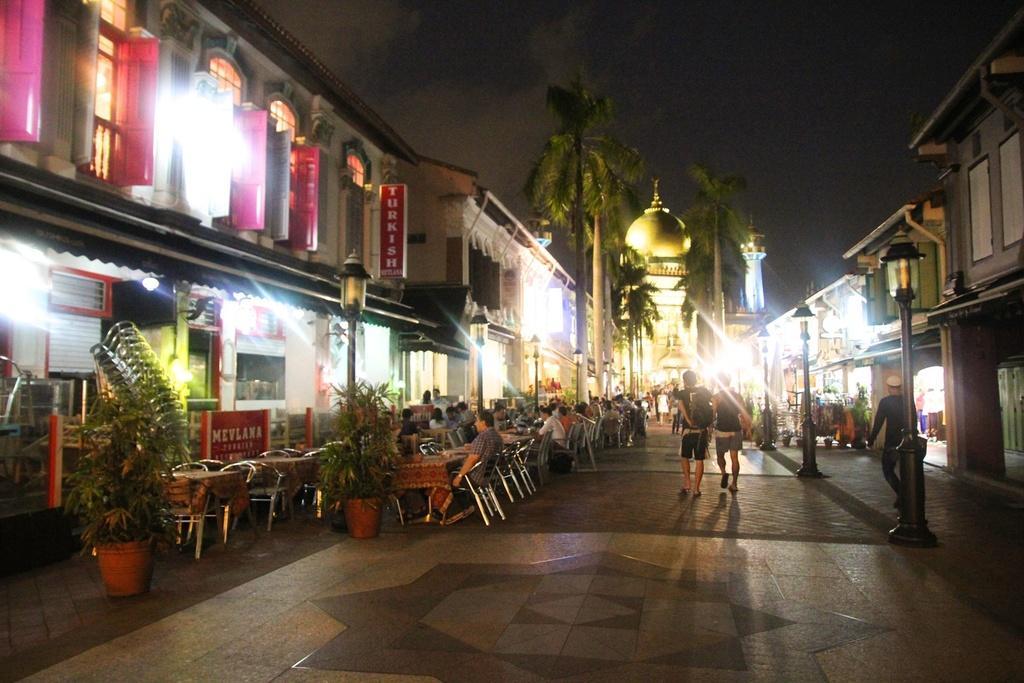In one or two sentences, can you explain what this image depicts? In this image, we can see persons wearing clothes. There are street poles and trees in between buildings. There are some persons sitting on chairs in front of tables. There are plants in front of the building. There is a sky at the top of the image. 